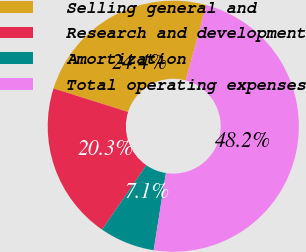Convert chart to OTSL. <chart><loc_0><loc_0><loc_500><loc_500><pie_chart><fcel>Selling general and<fcel>Research and development<fcel>Amortization<fcel>Total operating expenses<nl><fcel>24.38%<fcel>20.26%<fcel>7.11%<fcel>48.25%<nl></chart> 